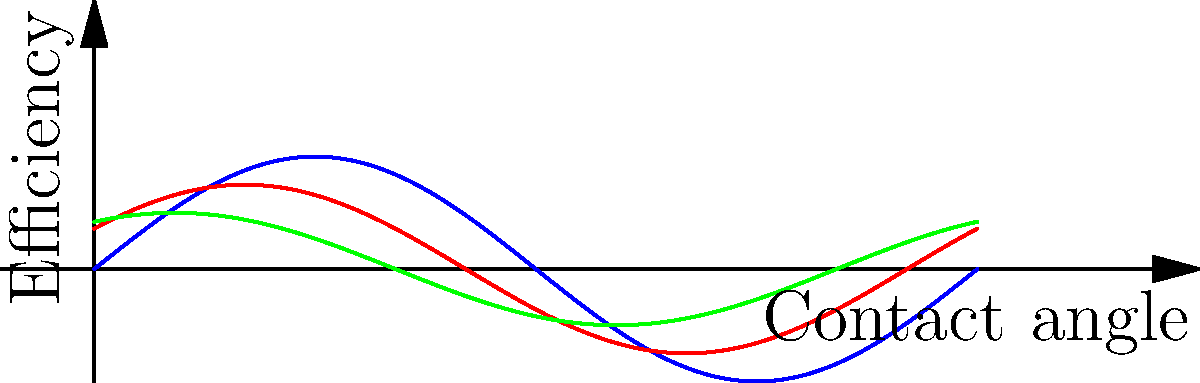As a supportive roommate helping your friend in recovery who's studying Mechanical Engineering, you come across a graph comparing the efficiency of different gear tooth profiles. Which tooth profile shows the highest overall efficiency across various contact angles? To determine which gear tooth profile has the highest overall efficiency, we need to analyze the graph:

1. The graph shows three curves representing different gear tooth profiles:
   - Blue curve: Involute profile
   - Red curve: Cycloidal profile
   - Green curve: Straight profile

2. The x-axis represents the contact angle, and the y-axis represents the efficiency.

3. We need to compare the overall height and area under each curve:
   - The blue curve (Involute) has the highest amplitude and covers the largest area.
   - The red curve (Cycloidal) has a medium amplitude and area.
   - The green curve (Straight) has the lowest amplitude and smallest area.

4. A higher curve indicates better efficiency across different contact angles.

5. The Involute profile (blue curve) consistently shows the highest efficiency throughout the range of contact angles.

Therefore, the Involute tooth profile demonstrates the highest overall efficiency across various contact angles.
Answer: Involute tooth profile 